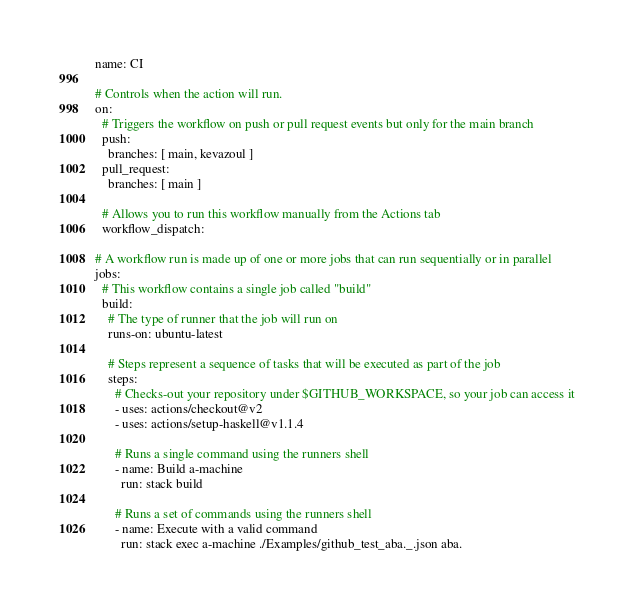Convert code to text. <code><loc_0><loc_0><loc_500><loc_500><_YAML_>name: CI

# Controls when the action will run. 
on:
  # Triggers the workflow on push or pull request events but only for the main branch
  push:
    branches: [ main, kevazoul ]
  pull_request:
    branches: [ main ]

  # Allows you to run this workflow manually from the Actions tab
  workflow_dispatch:

# A workflow run is made up of one or more jobs that can run sequentially or in parallel
jobs:
  # This workflow contains a single job called "build"
  build:
    # The type of runner that the job will run on
    runs-on: ubuntu-latest

    # Steps represent a sequence of tasks that will be executed as part of the job
    steps:
      # Checks-out your repository under $GITHUB_WORKSPACE, so your job can access it
      - uses: actions/checkout@v2
      - uses: actions/setup-haskell@v1.1.4

      # Runs a single command using the runners shell
      - name: Build a-machine
        run: stack build

      # Runs a set of commands using the runners shell
      - name: Execute with a valid command
        run: stack exec a-machine ./Examples/github_test_aba._.json aba.
</code> 